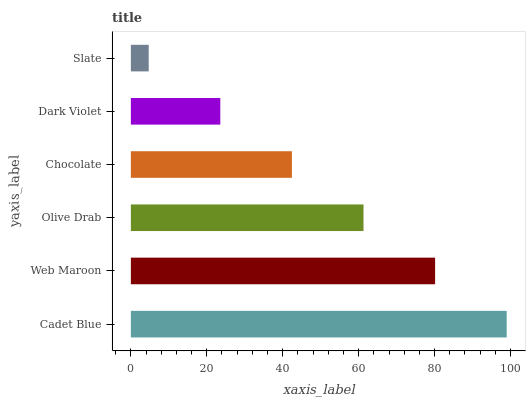Is Slate the minimum?
Answer yes or no. Yes. Is Cadet Blue the maximum?
Answer yes or no. Yes. Is Web Maroon the minimum?
Answer yes or no. No. Is Web Maroon the maximum?
Answer yes or no. No. Is Cadet Blue greater than Web Maroon?
Answer yes or no. Yes. Is Web Maroon less than Cadet Blue?
Answer yes or no. Yes. Is Web Maroon greater than Cadet Blue?
Answer yes or no. No. Is Cadet Blue less than Web Maroon?
Answer yes or no. No. Is Olive Drab the high median?
Answer yes or no. Yes. Is Chocolate the low median?
Answer yes or no. Yes. Is Cadet Blue the high median?
Answer yes or no. No. Is Dark Violet the low median?
Answer yes or no. No. 